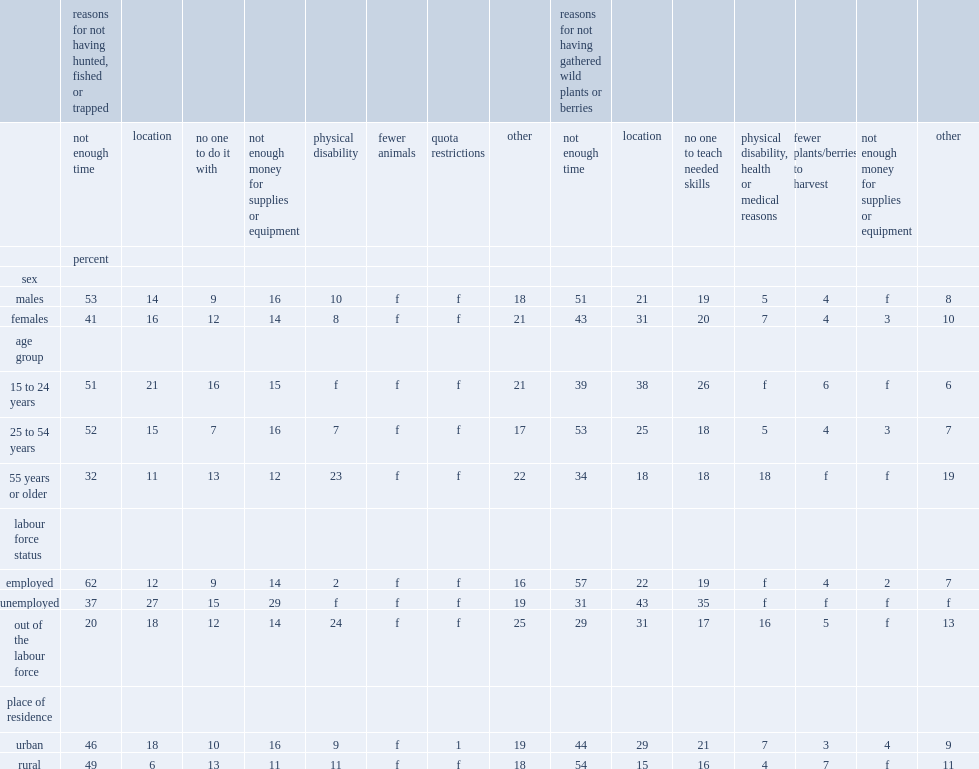By labour force status,who were most likely to cite time constraints as the reason for not participating? Employed. Who were more likely to cite monetary reasons,unemployed or employed individuals? Unemployed. What was the multiple relationship between those not in the labour force and those employed who cite physical disability as the reason for non-participation? 12. Who cited location as the reason for not having hunted, fished or trapped more,unemployed metis or employed metis? Unemployed. What were the percentages of urban and rural metis who cited location as the reason for not having hunted, fished or trapped respectively? 18.0 6.0. 